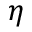<formula> <loc_0><loc_0><loc_500><loc_500>\eta</formula> 